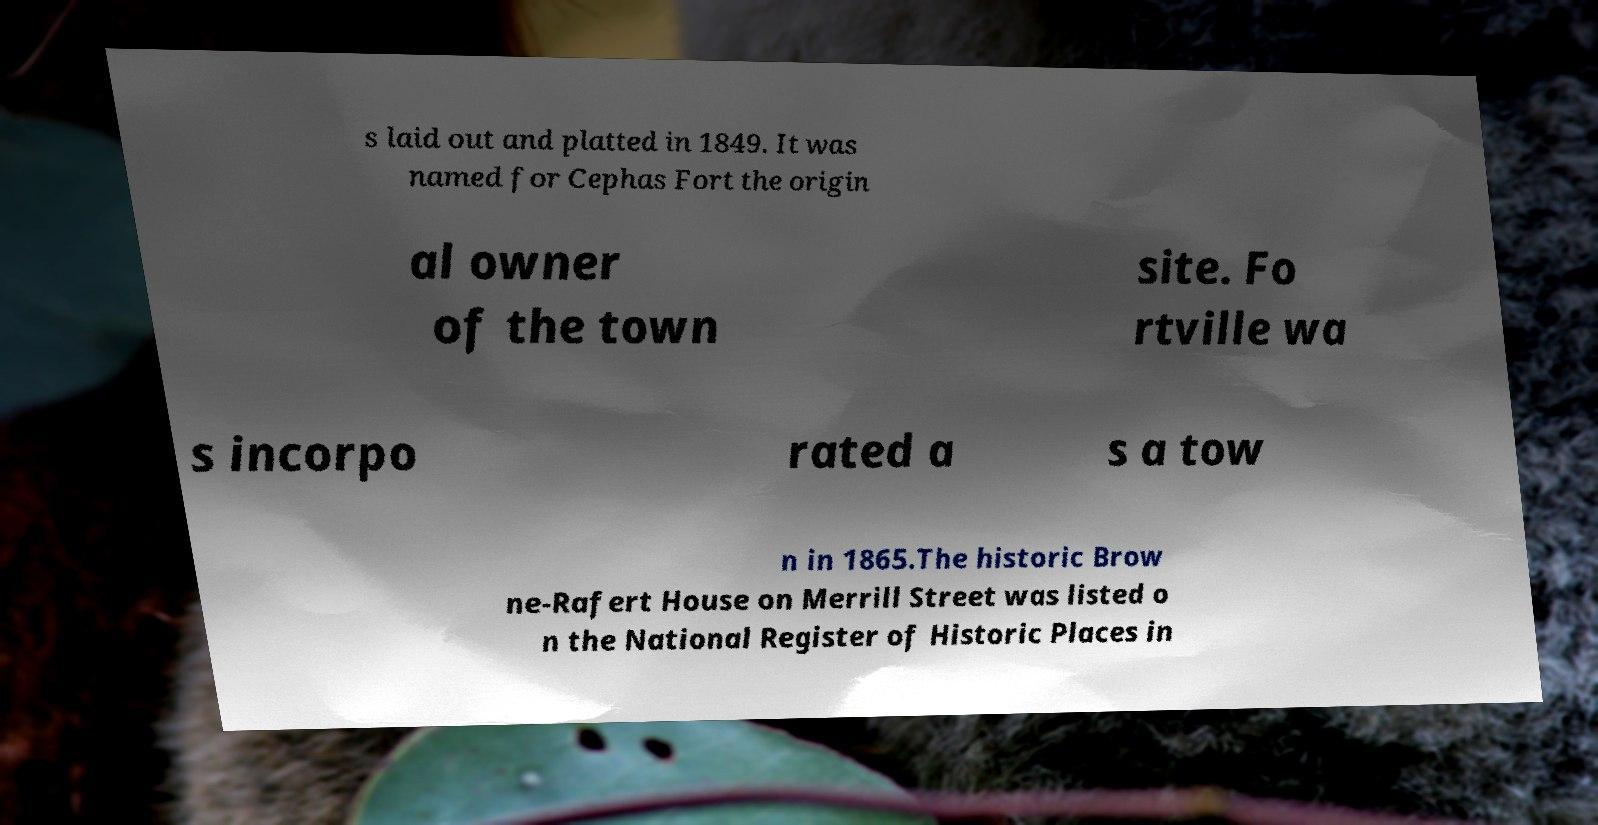I need the written content from this picture converted into text. Can you do that? s laid out and platted in 1849. It was named for Cephas Fort the origin al owner of the town site. Fo rtville wa s incorpo rated a s a tow n in 1865.The historic Brow ne-Rafert House on Merrill Street was listed o n the National Register of Historic Places in 